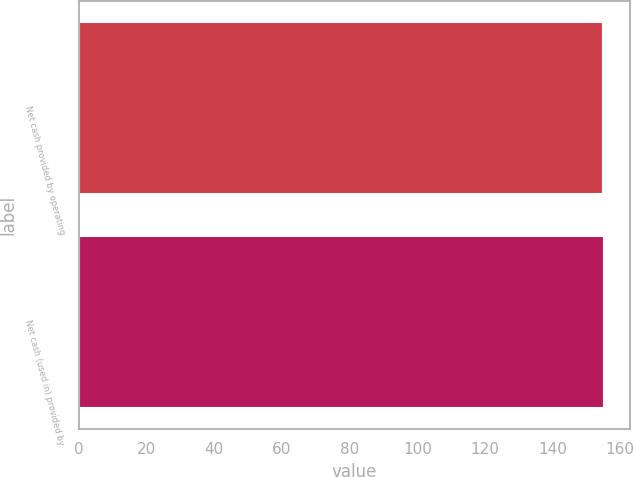Convert chart. <chart><loc_0><loc_0><loc_500><loc_500><bar_chart><fcel>Net cash provided by operating<fcel>Net cash (used in) provided by<nl><fcel>155<fcel>155.1<nl></chart> 